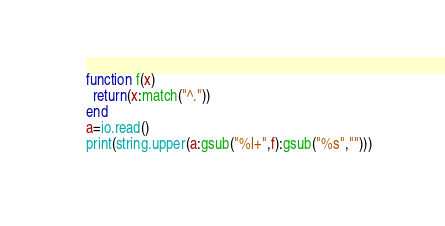Convert code to text. <code><loc_0><loc_0><loc_500><loc_500><_Lua_>function f(x)
  return(x:match("^."))
end
a=io.read()
print(string.upper(a:gsub("%l+",f):gsub("%s","")))</code> 